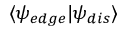Convert formula to latex. <formula><loc_0><loc_0><loc_500><loc_500>\langle \psi _ { e d g e } | \psi _ { d i s } \rangle</formula> 